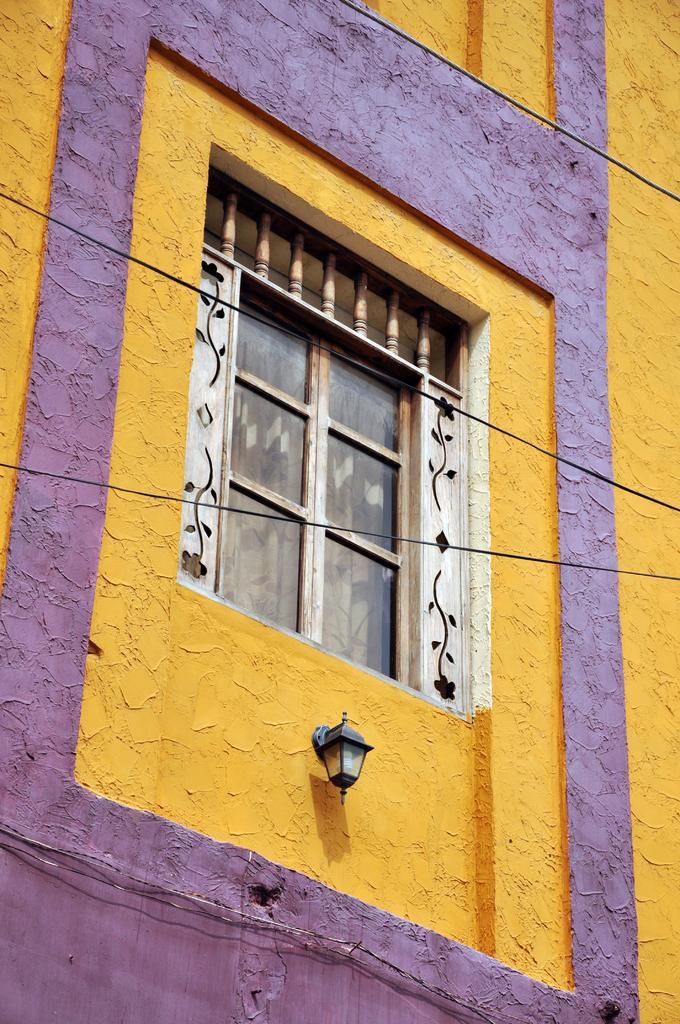In one or two sentences, can you explain what this image depicts? This is the picture of a building to which there is a window and a lamp. 